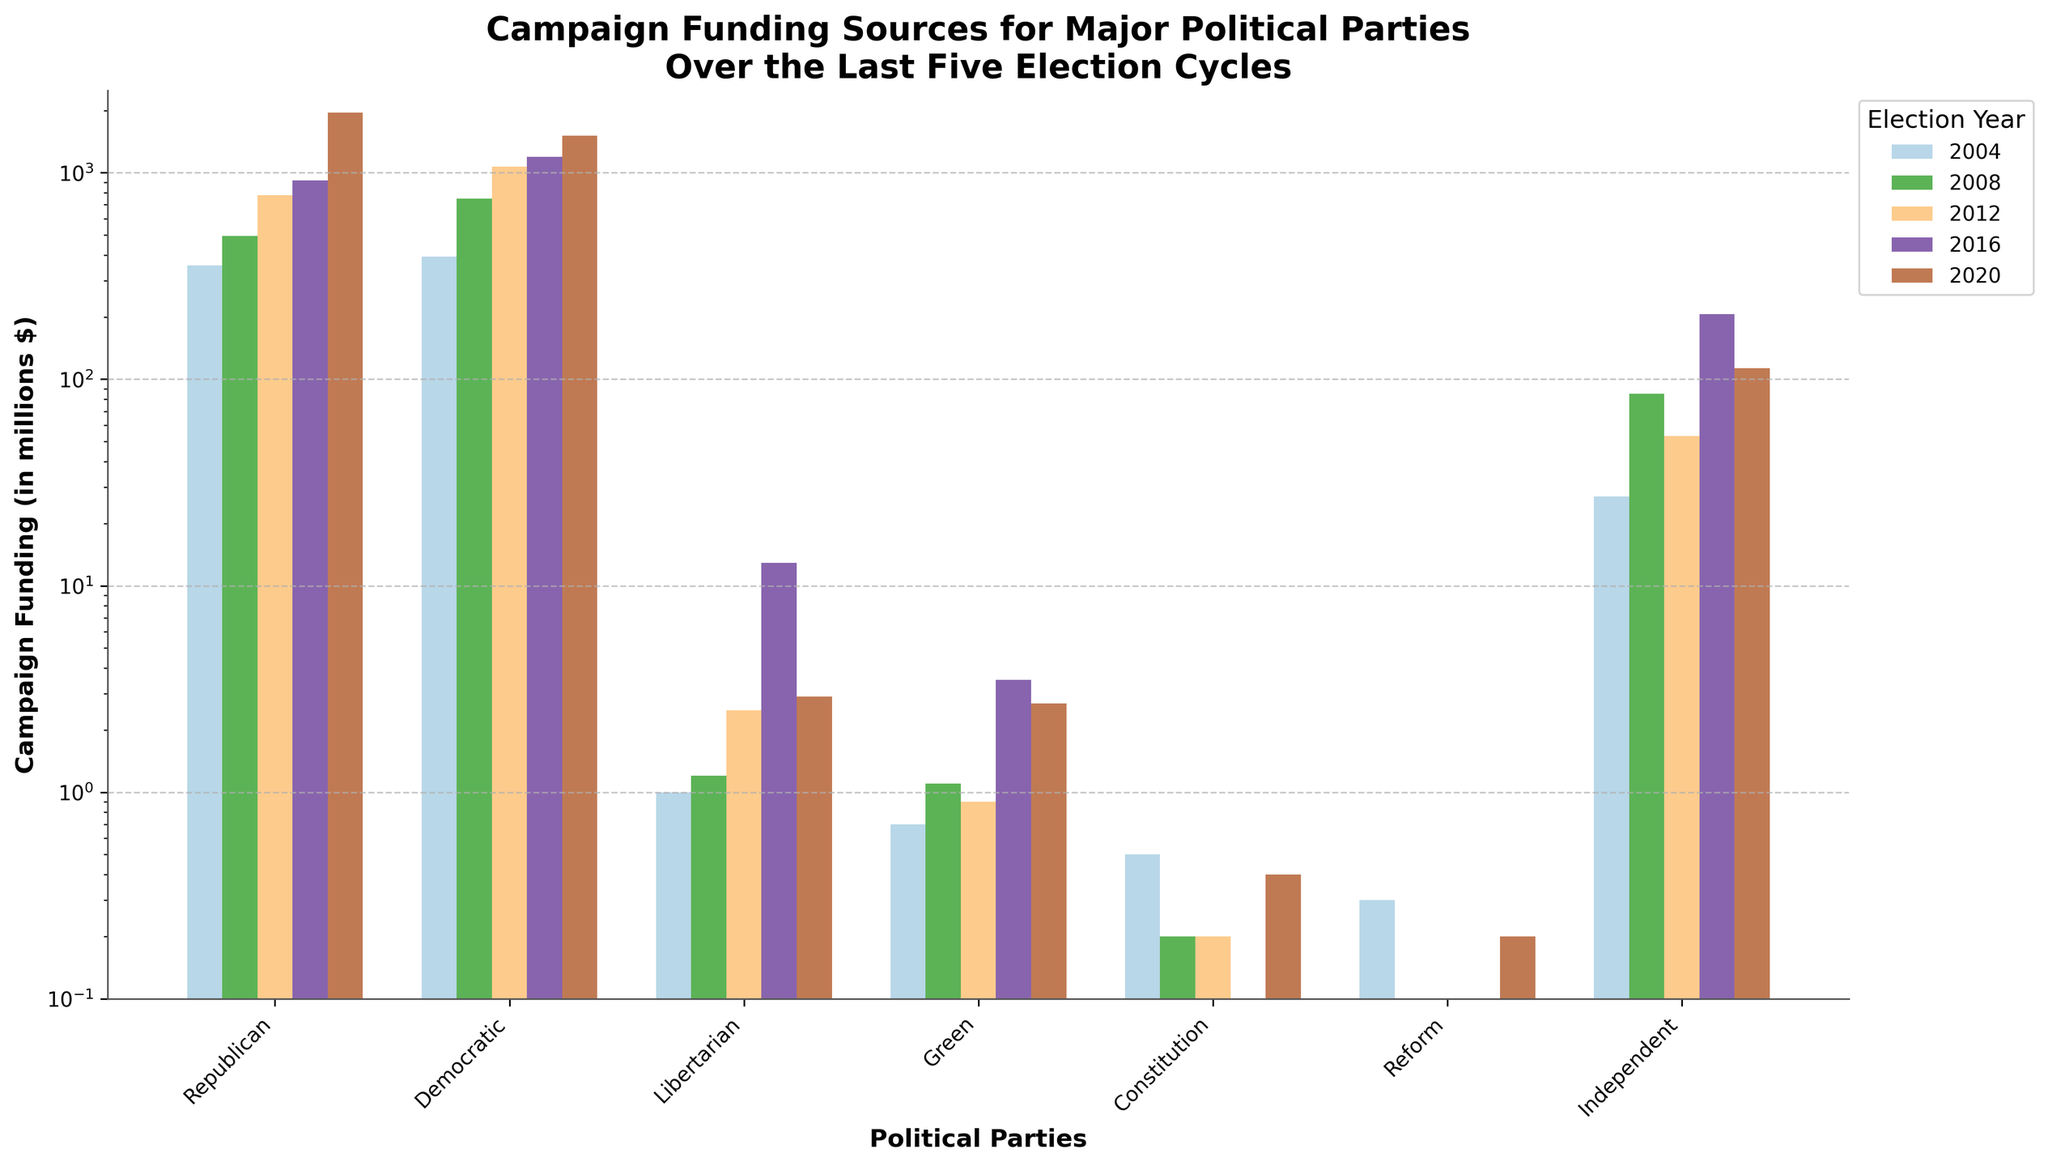Which political party had the highest campaign funding in the 2016 election cycle? By observing the heights of the bars for the 2016 cycle, the "Republican" party had the highest funding among all the parties.
Answer: Republican Which political party consistently had the lowest campaign funding across all election cycles? By comparing the bars across all election cycles, the "Reform" party consistently had the lowest funding.
Answer: Reform How did the campaign funding for the Democratic party change from 2004 to 2020? By subtracting the 2004 funding (392 million) from the 2020 funding (1512 million), the change is calculated as 1512 - 392 = 1120 million.
Answer: Increased by 1120 million Which election year saw the largest increase in funding for the Democratic party? By calculating the differences between successive years: 2008-2004 (748-392 = 356), 2012-2008 (1072-748 = 324), 2016-2012 (1191-1072 = 119), 2020-2016 (1512-1191 = 321), the largest increase occurred from 2004 to 2008 (356 million).
Answer: 2008 Which political party had a significant spike in funding in 2016 compared to other years? By visually inspecting the bars, the "Libertarian" party had a notable spike in funding in 2016 compared to other years.
Answer: Libertarian Compare the funding of the Independent party in 2008 and 2016. Which year had higher funding and by how much? The 2016 funding (207 million) was higher than the 2008 funding (85 million). The difference is 207 - 85 = 122 million.
Answer: 2016, by 122 million Which election cycle had the highest overall campaign funding when summing all parties' contributions? By summing the contributions for each cycle: 2004 (776.5), 2008 (1330.6), 2012 (1909.7), 2016 (2330.5), 2020 (3581.2), the highest overall funding was in 2020.
Answer: 2020 By how much did the campaign funding of the Republican party increase from 2016 to 2020? The increase from 2016 (916 million) to 2020 (1960 million) is calculated as 1960 - 916 = 1044 million.
Answer: 1044 million What is the average campaign funding of the Green party over the last five election cycles? Adding the Green party funding for all election cycles: 0.7 + 1.1 + 0.9 + 3.5 + 2.7 = 8.9, then dividing by 5: 8.9 / 5 = 1.78 million.
Answer: 1.78 million 